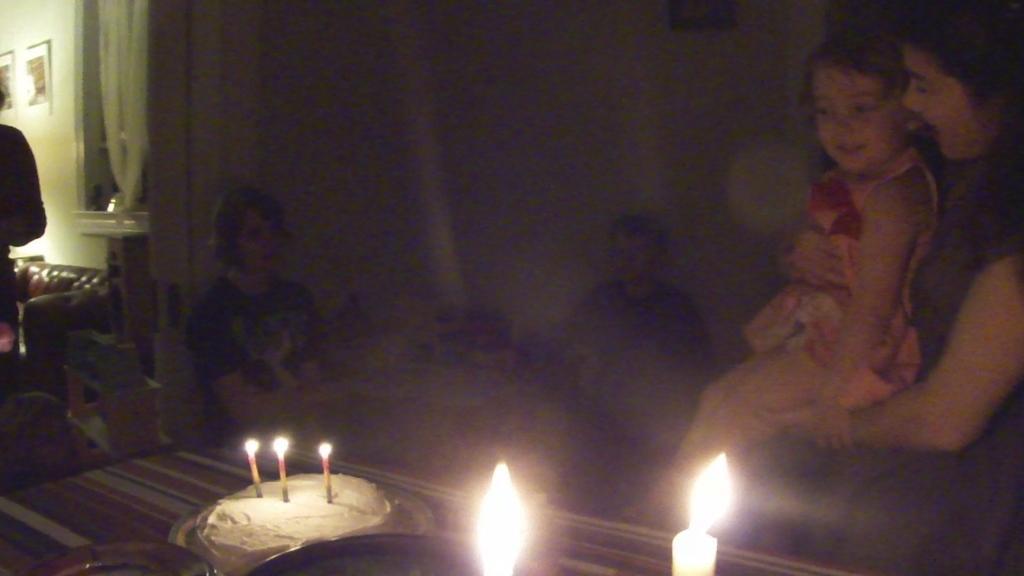Please provide a concise description of this image. In this image there is a table, on that table there is a cake and candles, beside the table there are people sitting on chairs, in the background there is a wall, a sofa and photo frames. 